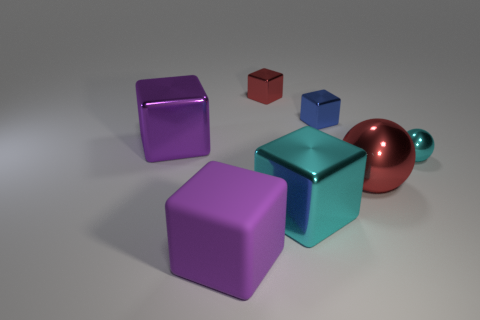Can you speculate on the material of the objects? The objects appear to have a matte finish except for the sphere, which has a reflective copper surface. As for the material, they could be composed of a type of painted wood or plastic based on their smooth surfaces and the way they reflect light. 